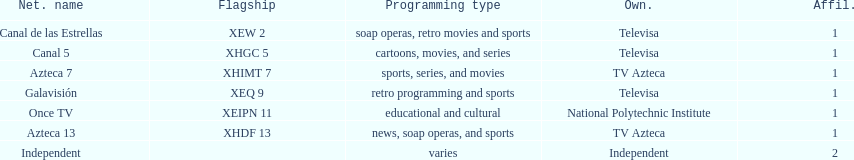Name a station that shows sports but is not televisa. Azteca 7. 